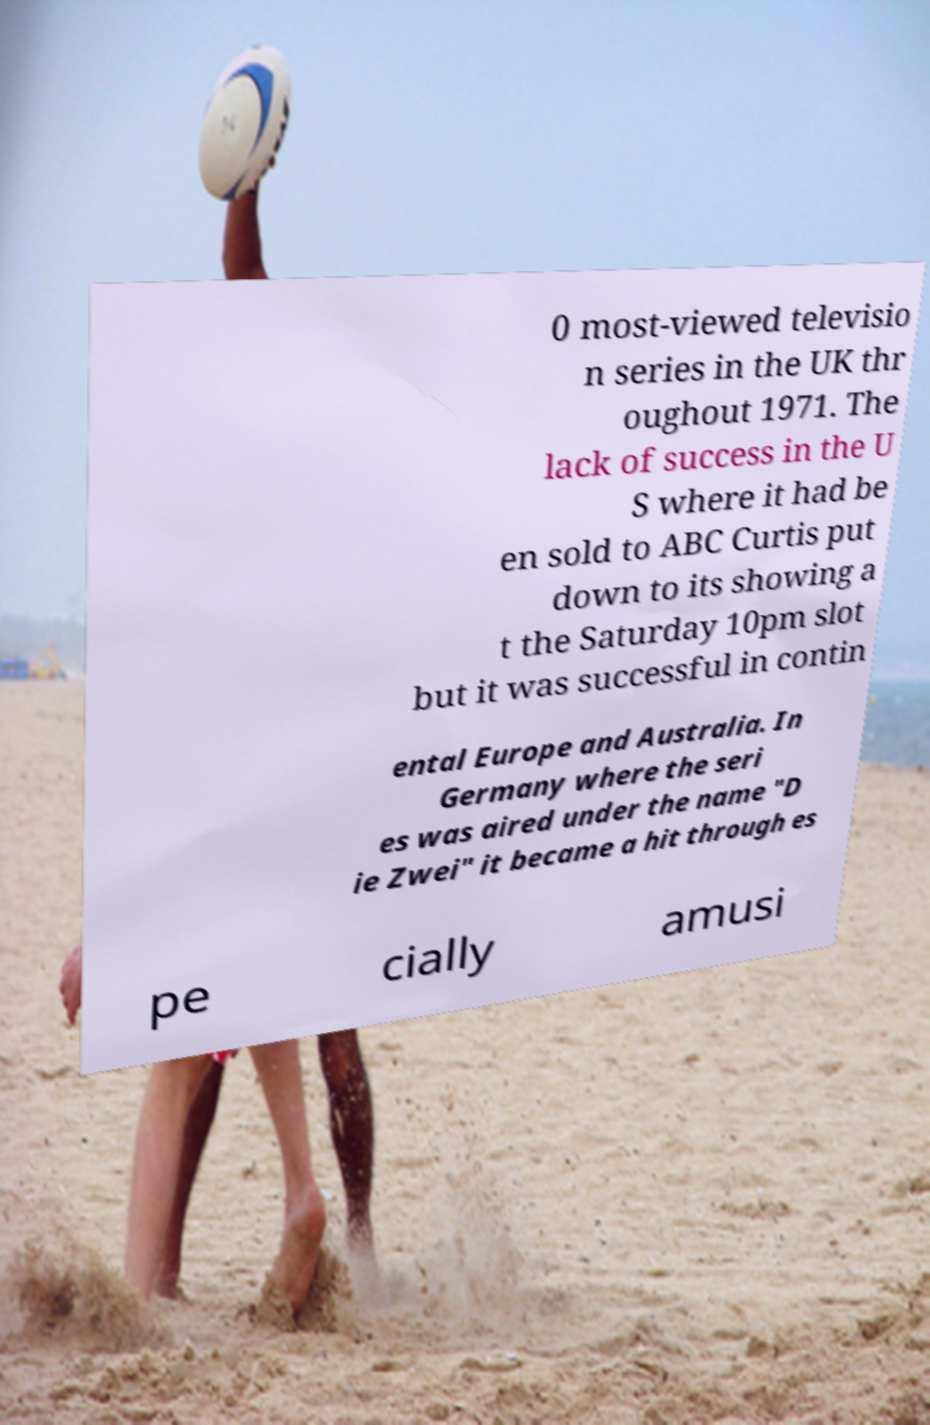I need the written content from this picture converted into text. Can you do that? 0 most-viewed televisio n series in the UK thr oughout 1971. The lack of success in the U S where it had be en sold to ABC Curtis put down to its showing a t the Saturday 10pm slot but it was successful in contin ental Europe and Australia. In Germany where the seri es was aired under the name "D ie Zwei" it became a hit through es pe cially amusi 